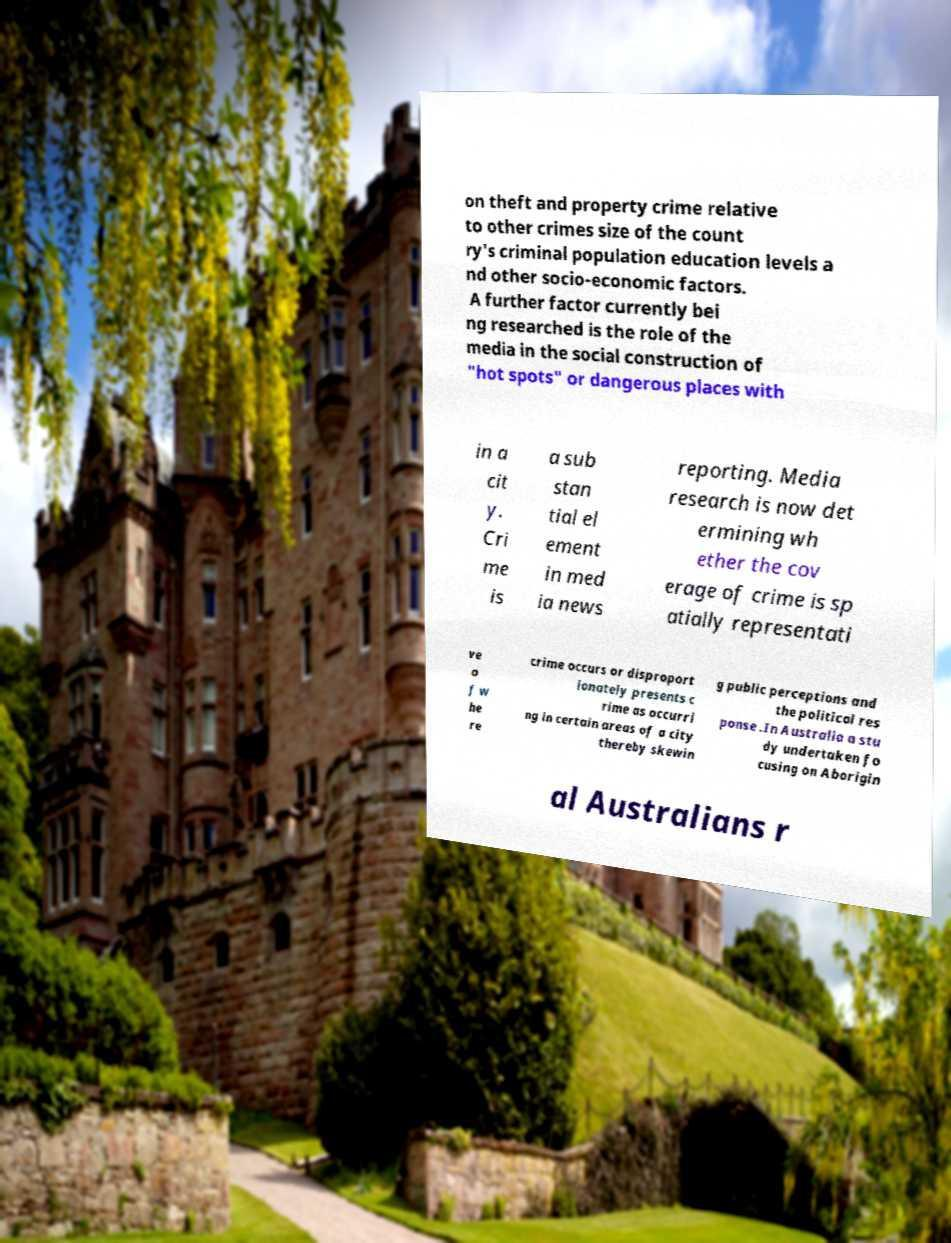Please read and relay the text visible in this image. What does it say? on theft and property crime relative to other crimes size of the count ry's criminal population education levels a nd other socio-economic factors. A further factor currently bei ng researched is the role of the media in the social construction of "hot spots" or dangerous places with in a cit y. Cri me is a sub stan tial el ement in med ia news reporting. Media research is now det ermining wh ether the cov erage of crime is sp atially representati ve o f w he re crime occurs or disproport ionately presents c rime as occurri ng in certain areas of a city thereby skewin g public perceptions and the political res ponse .In Australia a stu dy undertaken fo cusing on Aborigin al Australians r 